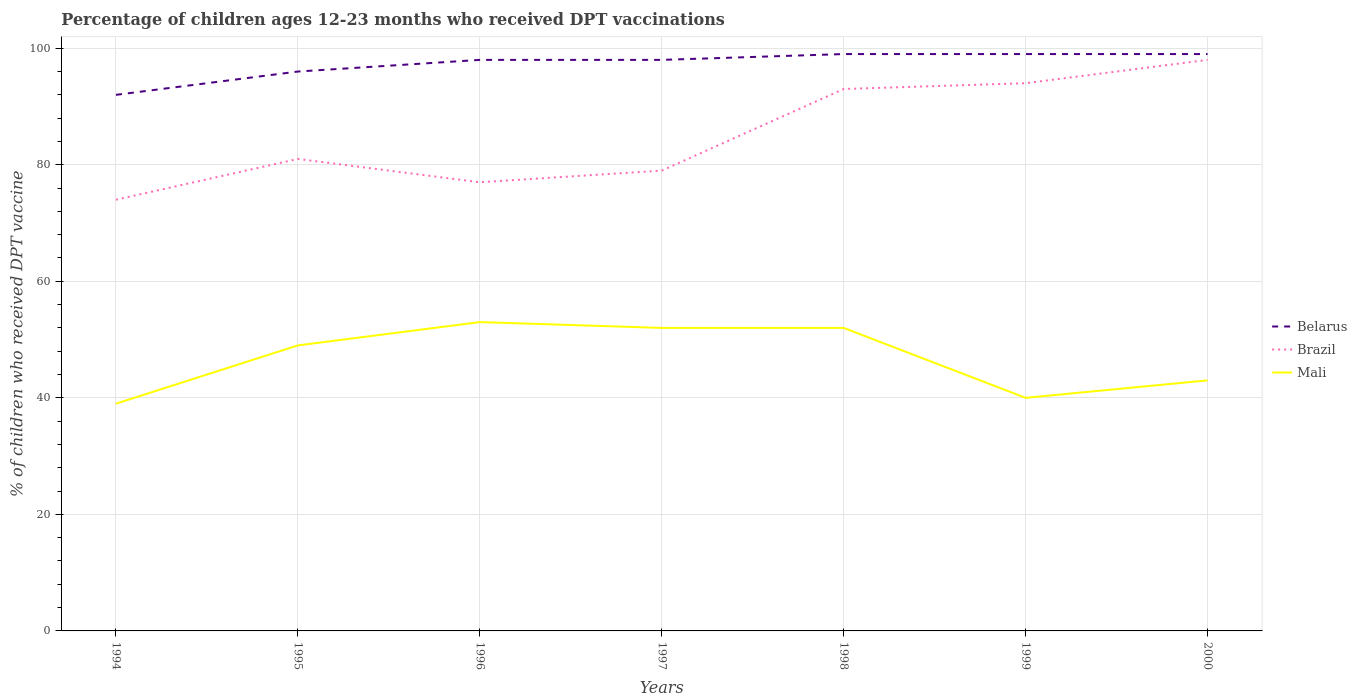How many different coloured lines are there?
Make the answer very short. 3. Does the line corresponding to Brazil intersect with the line corresponding to Belarus?
Your response must be concise. No. Across all years, what is the maximum percentage of children who received DPT vaccination in Belarus?
Provide a succinct answer. 92. What is the total percentage of children who received DPT vaccination in Belarus in the graph?
Ensure brevity in your answer.  -7. What is the difference between the highest and the second highest percentage of children who received DPT vaccination in Brazil?
Your answer should be very brief. 24. Is the percentage of children who received DPT vaccination in Belarus strictly greater than the percentage of children who received DPT vaccination in Brazil over the years?
Give a very brief answer. No. How many years are there in the graph?
Provide a succinct answer. 7. Are the values on the major ticks of Y-axis written in scientific E-notation?
Your answer should be very brief. No. Does the graph contain grids?
Your answer should be compact. Yes. Where does the legend appear in the graph?
Offer a terse response. Center right. How many legend labels are there?
Make the answer very short. 3. How are the legend labels stacked?
Ensure brevity in your answer.  Vertical. What is the title of the graph?
Make the answer very short. Percentage of children ages 12-23 months who received DPT vaccinations. Does "Albania" appear as one of the legend labels in the graph?
Your answer should be very brief. No. What is the label or title of the Y-axis?
Provide a succinct answer. % of children who received DPT vaccine. What is the % of children who received DPT vaccine in Belarus in 1994?
Your response must be concise. 92. What is the % of children who received DPT vaccine in Brazil in 1994?
Ensure brevity in your answer.  74. What is the % of children who received DPT vaccine of Mali in 1994?
Offer a very short reply. 39. What is the % of children who received DPT vaccine in Belarus in 1995?
Provide a succinct answer. 96. What is the % of children who received DPT vaccine of Belarus in 1996?
Offer a very short reply. 98. What is the % of children who received DPT vaccine of Brazil in 1996?
Ensure brevity in your answer.  77. What is the % of children who received DPT vaccine of Brazil in 1997?
Your answer should be very brief. 79. What is the % of children who received DPT vaccine in Brazil in 1998?
Offer a very short reply. 93. What is the % of children who received DPT vaccine in Belarus in 1999?
Provide a succinct answer. 99. What is the % of children who received DPT vaccine of Brazil in 1999?
Offer a terse response. 94. What is the % of children who received DPT vaccine of Mali in 2000?
Provide a short and direct response. 43. Across all years, what is the maximum % of children who received DPT vaccine of Belarus?
Give a very brief answer. 99. Across all years, what is the maximum % of children who received DPT vaccine in Mali?
Offer a terse response. 53. Across all years, what is the minimum % of children who received DPT vaccine in Belarus?
Provide a short and direct response. 92. Across all years, what is the minimum % of children who received DPT vaccine of Brazil?
Your answer should be very brief. 74. Across all years, what is the minimum % of children who received DPT vaccine of Mali?
Ensure brevity in your answer.  39. What is the total % of children who received DPT vaccine in Belarus in the graph?
Your answer should be very brief. 681. What is the total % of children who received DPT vaccine in Brazil in the graph?
Your response must be concise. 596. What is the total % of children who received DPT vaccine of Mali in the graph?
Ensure brevity in your answer.  328. What is the difference between the % of children who received DPT vaccine in Brazil in 1994 and that in 1995?
Your response must be concise. -7. What is the difference between the % of children who received DPT vaccine in Mali in 1994 and that in 1995?
Your answer should be compact. -10. What is the difference between the % of children who received DPT vaccine in Brazil in 1994 and that in 1996?
Provide a short and direct response. -3. What is the difference between the % of children who received DPT vaccine of Brazil in 1994 and that in 1997?
Provide a succinct answer. -5. What is the difference between the % of children who received DPT vaccine of Mali in 1994 and that in 1997?
Offer a terse response. -13. What is the difference between the % of children who received DPT vaccine in Belarus in 1994 and that in 1998?
Keep it short and to the point. -7. What is the difference between the % of children who received DPT vaccine in Mali in 1994 and that in 1998?
Provide a short and direct response. -13. What is the difference between the % of children who received DPT vaccine in Brazil in 1994 and that in 1999?
Your answer should be very brief. -20. What is the difference between the % of children who received DPT vaccine in Mali in 1994 and that in 1999?
Offer a very short reply. -1. What is the difference between the % of children who received DPT vaccine of Brazil in 1994 and that in 2000?
Provide a short and direct response. -24. What is the difference between the % of children who received DPT vaccine of Brazil in 1995 and that in 1996?
Your response must be concise. 4. What is the difference between the % of children who received DPT vaccine of Belarus in 1995 and that in 1998?
Offer a terse response. -3. What is the difference between the % of children who received DPT vaccine in Mali in 1995 and that in 1998?
Offer a terse response. -3. What is the difference between the % of children who received DPT vaccine of Brazil in 1995 and that in 1999?
Provide a succinct answer. -13. What is the difference between the % of children who received DPT vaccine of Mali in 1995 and that in 1999?
Offer a very short reply. 9. What is the difference between the % of children who received DPT vaccine in Belarus in 1995 and that in 2000?
Your response must be concise. -3. What is the difference between the % of children who received DPT vaccine of Mali in 1995 and that in 2000?
Make the answer very short. 6. What is the difference between the % of children who received DPT vaccine of Mali in 1996 and that in 1997?
Your answer should be very brief. 1. What is the difference between the % of children who received DPT vaccine of Belarus in 1996 and that in 1998?
Provide a short and direct response. -1. What is the difference between the % of children who received DPT vaccine in Brazil in 1996 and that in 1998?
Keep it short and to the point. -16. What is the difference between the % of children who received DPT vaccine in Mali in 1996 and that in 1998?
Your answer should be very brief. 1. What is the difference between the % of children who received DPT vaccine of Belarus in 1996 and that in 1999?
Provide a short and direct response. -1. What is the difference between the % of children who received DPT vaccine in Brazil in 1996 and that in 1999?
Your answer should be very brief. -17. What is the difference between the % of children who received DPT vaccine in Mali in 1996 and that in 1999?
Offer a terse response. 13. What is the difference between the % of children who received DPT vaccine of Brazil in 1996 and that in 2000?
Provide a short and direct response. -21. What is the difference between the % of children who received DPT vaccine in Brazil in 1997 and that in 1998?
Keep it short and to the point. -14. What is the difference between the % of children who received DPT vaccine in Brazil in 1997 and that in 1999?
Provide a short and direct response. -15. What is the difference between the % of children who received DPT vaccine in Mali in 1997 and that in 1999?
Make the answer very short. 12. What is the difference between the % of children who received DPT vaccine of Brazil in 1998 and that in 1999?
Make the answer very short. -1. What is the difference between the % of children who received DPT vaccine of Brazil in 1998 and that in 2000?
Your response must be concise. -5. What is the difference between the % of children who received DPT vaccine of Mali in 1998 and that in 2000?
Provide a short and direct response. 9. What is the difference between the % of children who received DPT vaccine of Mali in 1999 and that in 2000?
Your response must be concise. -3. What is the difference between the % of children who received DPT vaccine of Belarus in 1994 and the % of children who received DPT vaccine of Mali in 1996?
Provide a short and direct response. 39. What is the difference between the % of children who received DPT vaccine of Brazil in 1994 and the % of children who received DPT vaccine of Mali in 1996?
Offer a very short reply. 21. What is the difference between the % of children who received DPT vaccine in Belarus in 1994 and the % of children who received DPT vaccine in Brazil in 1997?
Your answer should be compact. 13. What is the difference between the % of children who received DPT vaccine in Brazil in 1994 and the % of children who received DPT vaccine in Mali in 1997?
Keep it short and to the point. 22. What is the difference between the % of children who received DPT vaccine of Belarus in 1994 and the % of children who received DPT vaccine of Mali in 1998?
Your answer should be compact. 40. What is the difference between the % of children who received DPT vaccine of Belarus in 1994 and the % of children who received DPT vaccine of Mali in 1999?
Offer a very short reply. 52. What is the difference between the % of children who received DPT vaccine of Brazil in 1994 and the % of children who received DPT vaccine of Mali in 1999?
Provide a succinct answer. 34. What is the difference between the % of children who received DPT vaccine in Belarus in 1994 and the % of children who received DPT vaccine in Mali in 2000?
Your answer should be very brief. 49. What is the difference between the % of children who received DPT vaccine in Brazil in 1994 and the % of children who received DPT vaccine in Mali in 2000?
Provide a succinct answer. 31. What is the difference between the % of children who received DPT vaccine in Belarus in 1995 and the % of children who received DPT vaccine in Brazil in 1996?
Your response must be concise. 19. What is the difference between the % of children who received DPT vaccine of Belarus in 1995 and the % of children who received DPT vaccine of Brazil in 1997?
Your response must be concise. 17. What is the difference between the % of children who received DPT vaccine of Belarus in 1995 and the % of children who received DPT vaccine of Mali in 1997?
Provide a short and direct response. 44. What is the difference between the % of children who received DPT vaccine of Brazil in 1995 and the % of children who received DPT vaccine of Mali in 1998?
Offer a terse response. 29. What is the difference between the % of children who received DPT vaccine in Belarus in 1995 and the % of children who received DPT vaccine in Mali in 1999?
Give a very brief answer. 56. What is the difference between the % of children who received DPT vaccine in Belarus in 1995 and the % of children who received DPT vaccine in Brazil in 2000?
Provide a succinct answer. -2. What is the difference between the % of children who received DPT vaccine of Belarus in 1995 and the % of children who received DPT vaccine of Mali in 2000?
Offer a very short reply. 53. What is the difference between the % of children who received DPT vaccine in Brazil in 1995 and the % of children who received DPT vaccine in Mali in 2000?
Offer a very short reply. 38. What is the difference between the % of children who received DPT vaccine of Brazil in 1996 and the % of children who received DPT vaccine of Mali in 1997?
Ensure brevity in your answer.  25. What is the difference between the % of children who received DPT vaccine of Belarus in 1996 and the % of children who received DPT vaccine of Brazil in 1998?
Make the answer very short. 5. What is the difference between the % of children who received DPT vaccine in Belarus in 1996 and the % of children who received DPT vaccine in Mali in 1998?
Offer a very short reply. 46. What is the difference between the % of children who received DPT vaccine of Belarus in 1996 and the % of children who received DPT vaccine of Brazil in 1999?
Offer a very short reply. 4. What is the difference between the % of children who received DPT vaccine of Brazil in 1996 and the % of children who received DPT vaccine of Mali in 1999?
Provide a succinct answer. 37. What is the difference between the % of children who received DPT vaccine in Brazil in 1996 and the % of children who received DPT vaccine in Mali in 2000?
Give a very brief answer. 34. What is the difference between the % of children who received DPT vaccine of Belarus in 1997 and the % of children who received DPT vaccine of Brazil in 1998?
Offer a terse response. 5. What is the difference between the % of children who received DPT vaccine in Belarus in 1997 and the % of children who received DPT vaccine in Mali in 1999?
Make the answer very short. 58. What is the difference between the % of children who received DPT vaccine of Brazil in 1997 and the % of children who received DPT vaccine of Mali in 1999?
Ensure brevity in your answer.  39. What is the difference between the % of children who received DPT vaccine of Brazil in 1997 and the % of children who received DPT vaccine of Mali in 2000?
Give a very brief answer. 36. What is the difference between the % of children who received DPT vaccine of Belarus in 1998 and the % of children who received DPT vaccine of Brazil in 1999?
Give a very brief answer. 5. What is the difference between the % of children who received DPT vaccine in Brazil in 1998 and the % of children who received DPT vaccine in Mali in 1999?
Make the answer very short. 53. What is the difference between the % of children who received DPT vaccine in Belarus in 1999 and the % of children who received DPT vaccine in Brazil in 2000?
Your answer should be very brief. 1. What is the difference between the % of children who received DPT vaccine in Belarus in 1999 and the % of children who received DPT vaccine in Mali in 2000?
Keep it short and to the point. 56. What is the average % of children who received DPT vaccine in Belarus per year?
Make the answer very short. 97.29. What is the average % of children who received DPT vaccine in Brazil per year?
Provide a succinct answer. 85.14. What is the average % of children who received DPT vaccine in Mali per year?
Provide a succinct answer. 46.86. In the year 1995, what is the difference between the % of children who received DPT vaccine in Belarus and % of children who received DPT vaccine in Brazil?
Give a very brief answer. 15. In the year 1995, what is the difference between the % of children who received DPT vaccine of Belarus and % of children who received DPT vaccine of Mali?
Provide a succinct answer. 47. In the year 1995, what is the difference between the % of children who received DPT vaccine in Brazil and % of children who received DPT vaccine in Mali?
Ensure brevity in your answer.  32. In the year 1996, what is the difference between the % of children who received DPT vaccine in Brazil and % of children who received DPT vaccine in Mali?
Offer a terse response. 24. In the year 1998, what is the difference between the % of children who received DPT vaccine in Belarus and % of children who received DPT vaccine in Brazil?
Your response must be concise. 6. In the year 1998, what is the difference between the % of children who received DPT vaccine of Brazil and % of children who received DPT vaccine of Mali?
Offer a terse response. 41. In the year 1999, what is the difference between the % of children who received DPT vaccine of Brazil and % of children who received DPT vaccine of Mali?
Your answer should be compact. 54. In the year 2000, what is the difference between the % of children who received DPT vaccine in Belarus and % of children who received DPT vaccine in Mali?
Provide a succinct answer. 56. In the year 2000, what is the difference between the % of children who received DPT vaccine of Brazil and % of children who received DPT vaccine of Mali?
Keep it short and to the point. 55. What is the ratio of the % of children who received DPT vaccine in Belarus in 1994 to that in 1995?
Give a very brief answer. 0.96. What is the ratio of the % of children who received DPT vaccine of Brazil in 1994 to that in 1995?
Your response must be concise. 0.91. What is the ratio of the % of children who received DPT vaccine in Mali in 1994 to that in 1995?
Offer a terse response. 0.8. What is the ratio of the % of children who received DPT vaccine of Belarus in 1994 to that in 1996?
Your answer should be very brief. 0.94. What is the ratio of the % of children who received DPT vaccine in Brazil in 1994 to that in 1996?
Ensure brevity in your answer.  0.96. What is the ratio of the % of children who received DPT vaccine in Mali in 1994 to that in 1996?
Offer a very short reply. 0.74. What is the ratio of the % of children who received DPT vaccine in Belarus in 1994 to that in 1997?
Offer a terse response. 0.94. What is the ratio of the % of children who received DPT vaccine of Brazil in 1994 to that in 1997?
Your answer should be very brief. 0.94. What is the ratio of the % of children who received DPT vaccine in Mali in 1994 to that in 1997?
Keep it short and to the point. 0.75. What is the ratio of the % of children who received DPT vaccine of Belarus in 1994 to that in 1998?
Offer a very short reply. 0.93. What is the ratio of the % of children who received DPT vaccine of Brazil in 1994 to that in 1998?
Keep it short and to the point. 0.8. What is the ratio of the % of children who received DPT vaccine of Mali in 1994 to that in 1998?
Provide a succinct answer. 0.75. What is the ratio of the % of children who received DPT vaccine in Belarus in 1994 to that in 1999?
Ensure brevity in your answer.  0.93. What is the ratio of the % of children who received DPT vaccine in Brazil in 1994 to that in 1999?
Your answer should be very brief. 0.79. What is the ratio of the % of children who received DPT vaccine of Mali in 1994 to that in 1999?
Offer a very short reply. 0.97. What is the ratio of the % of children who received DPT vaccine in Belarus in 1994 to that in 2000?
Your response must be concise. 0.93. What is the ratio of the % of children who received DPT vaccine in Brazil in 1994 to that in 2000?
Make the answer very short. 0.76. What is the ratio of the % of children who received DPT vaccine in Mali in 1994 to that in 2000?
Your response must be concise. 0.91. What is the ratio of the % of children who received DPT vaccine of Belarus in 1995 to that in 1996?
Provide a short and direct response. 0.98. What is the ratio of the % of children who received DPT vaccine in Brazil in 1995 to that in 1996?
Your answer should be compact. 1.05. What is the ratio of the % of children who received DPT vaccine in Mali in 1995 to that in 1996?
Provide a succinct answer. 0.92. What is the ratio of the % of children who received DPT vaccine in Belarus in 1995 to that in 1997?
Your answer should be very brief. 0.98. What is the ratio of the % of children who received DPT vaccine of Brazil in 1995 to that in 1997?
Ensure brevity in your answer.  1.03. What is the ratio of the % of children who received DPT vaccine in Mali in 1995 to that in 1997?
Provide a succinct answer. 0.94. What is the ratio of the % of children who received DPT vaccine of Belarus in 1995 to that in 1998?
Keep it short and to the point. 0.97. What is the ratio of the % of children who received DPT vaccine of Brazil in 1995 to that in 1998?
Provide a short and direct response. 0.87. What is the ratio of the % of children who received DPT vaccine of Mali in 1995 to that in 1998?
Make the answer very short. 0.94. What is the ratio of the % of children who received DPT vaccine in Belarus in 1995 to that in 1999?
Your answer should be very brief. 0.97. What is the ratio of the % of children who received DPT vaccine in Brazil in 1995 to that in 1999?
Provide a short and direct response. 0.86. What is the ratio of the % of children who received DPT vaccine in Mali in 1995 to that in 1999?
Offer a terse response. 1.23. What is the ratio of the % of children who received DPT vaccine of Belarus in 1995 to that in 2000?
Keep it short and to the point. 0.97. What is the ratio of the % of children who received DPT vaccine in Brazil in 1995 to that in 2000?
Keep it short and to the point. 0.83. What is the ratio of the % of children who received DPT vaccine of Mali in 1995 to that in 2000?
Provide a succinct answer. 1.14. What is the ratio of the % of children who received DPT vaccine of Brazil in 1996 to that in 1997?
Offer a terse response. 0.97. What is the ratio of the % of children who received DPT vaccine in Mali in 1996 to that in 1997?
Offer a very short reply. 1.02. What is the ratio of the % of children who received DPT vaccine in Brazil in 1996 to that in 1998?
Provide a succinct answer. 0.83. What is the ratio of the % of children who received DPT vaccine of Mali in 1996 to that in 1998?
Provide a short and direct response. 1.02. What is the ratio of the % of children who received DPT vaccine in Belarus in 1996 to that in 1999?
Ensure brevity in your answer.  0.99. What is the ratio of the % of children who received DPT vaccine in Brazil in 1996 to that in 1999?
Keep it short and to the point. 0.82. What is the ratio of the % of children who received DPT vaccine in Mali in 1996 to that in 1999?
Your answer should be compact. 1.32. What is the ratio of the % of children who received DPT vaccine of Brazil in 1996 to that in 2000?
Ensure brevity in your answer.  0.79. What is the ratio of the % of children who received DPT vaccine in Mali in 1996 to that in 2000?
Give a very brief answer. 1.23. What is the ratio of the % of children who received DPT vaccine of Brazil in 1997 to that in 1998?
Provide a short and direct response. 0.85. What is the ratio of the % of children who received DPT vaccine in Brazil in 1997 to that in 1999?
Keep it short and to the point. 0.84. What is the ratio of the % of children who received DPT vaccine in Mali in 1997 to that in 1999?
Ensure brevity in your answer.  1.3. What is the ratio of the % of children who received DPT vaccine in Brazil in 1997 to that in 2000?
Make the answer very short. 0.81. What is the ratio of the % of children who received DPT vaccine of Mali in 1997 to that in 2000?
Make the answer very short. 1.21. What is the ratio of the % of children who received DPT vaccine in Brazil in 1998 to that in 2000?
Offer a terse response. 0.95. What is the ratio of the % of children who received DPT vaccine in Mali in 1998 to that in 2000?
Your answer should be compact. 1.21. What is the ratio of the % of children who received DPT vaccine in Belarus in 1999 to that in 2000?
Provide a succinct answer. 1. What is the ratio of the % of children who received DPT vaccine in Brazil in 1999 to that in 2000?
Provide a succinct answer. 0.96. What is the ratio of the % of children who received DPT vaccine in Mali in 1999 to that in 2000?
Your answer should be compact. 0.93. What is the difference between the highest and the second highest % of children who received DPT vaccine of Belarus?
Your response must be concise. 0. What is the difference between the highest and the second highest % of children who received DPT vaccine of Brazil?
Provide a succinct answer. 4. What is the difference between the highest and the second highest % of children who received DPT vaccine of Mali?
Keep it short and to the point. 1. What is the difference between the highest and the lowest % of children who received DPT vaccine of Belarus?
Your answer should be very brief. 7. 